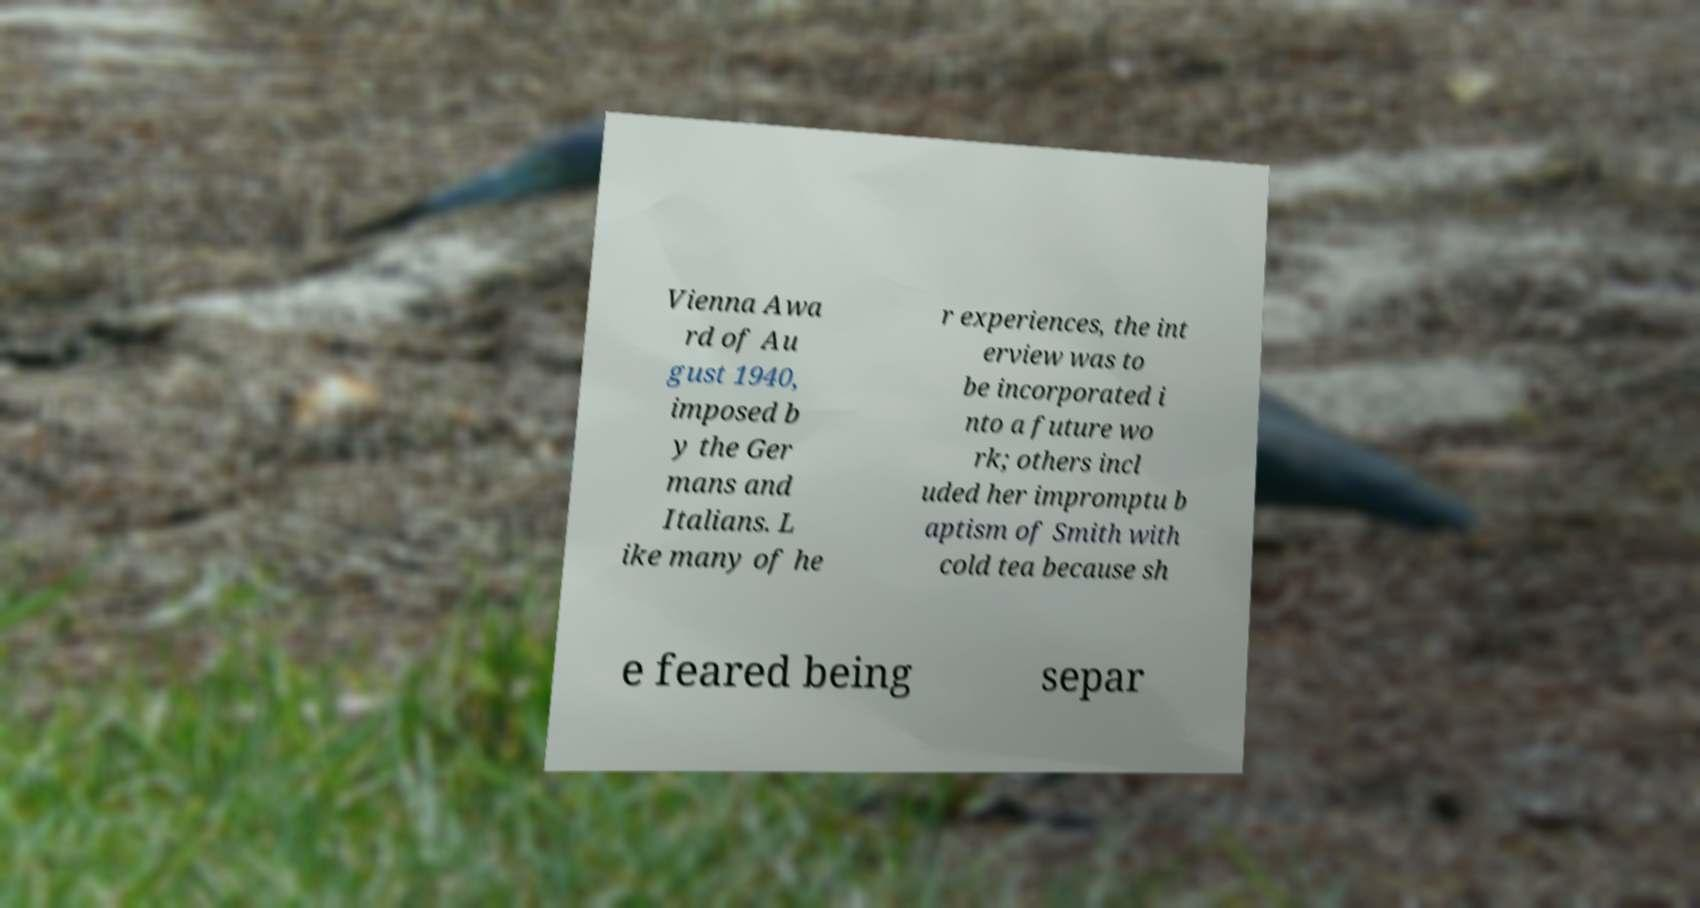Please identify and transcribe the text found in this image. Vienna Awa rd of Au gust 1940, imposed b y the Ger mans and Italians. L ike many of he r experiences, the int erview was to be incorporated i nto a future wo rk; others incl uded her impromptu b aptism of Smith with cold tea because sh e feared being separ 